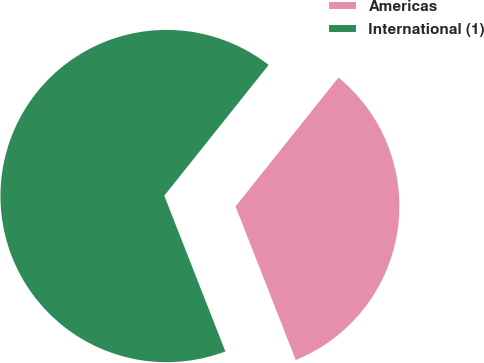Convert chart to OTSL. <chart><loc_0><loc_0><loc_500><loc_500><pie_chart><fcel>Americas<fcel>International (1)<nl><fcel>33.33%<fcel>66.67%<nl></chart> 